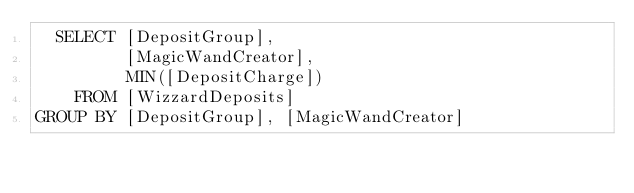Convert code to text. <code><loc_0><loc_0><loc_500><loc_500><_SQL_>  SELECT [DepositGroup], 
         [MagicWandCreator],
		 MIN([DepositCharge]) 
	FROM [WizzardDeposits] 
GROUP BY [DepositGroup], [MagicWandCreator]</code> 